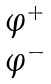Convert formula to latex. <formula><loc_0><loc_0><loc_500><loc_500>\begin{matrix} \varphi ^ { + } \\ \varphi ^ { - } \end{matrix}</formula> 